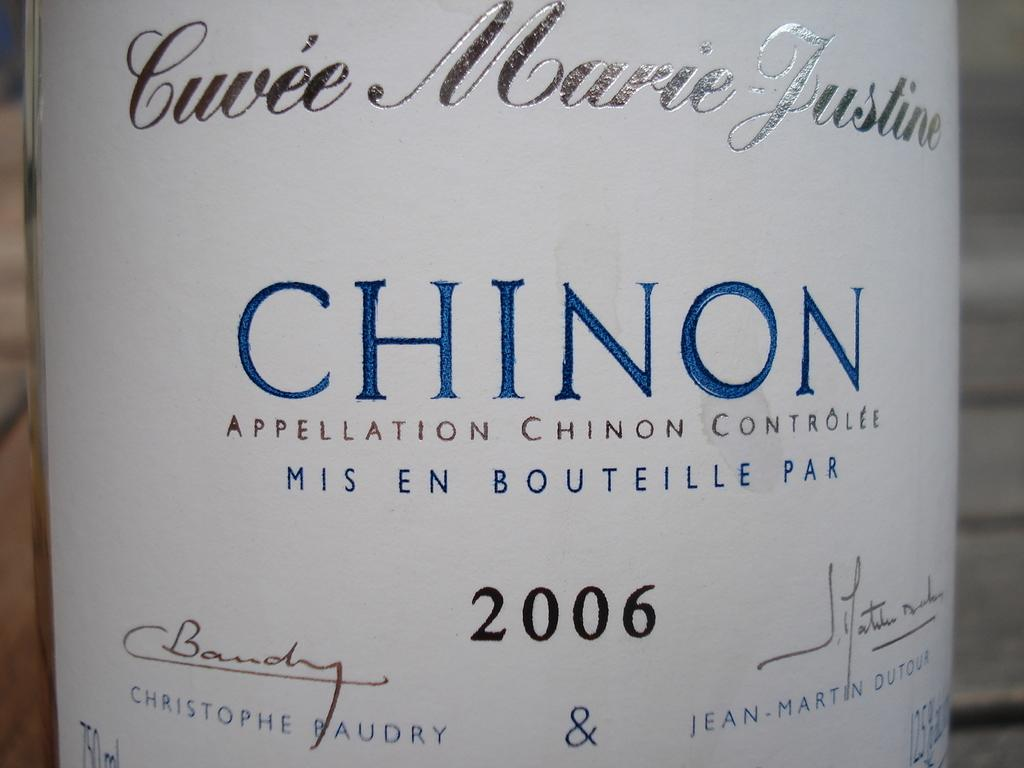<image>
Render a clear and concise summary of the photo. the year 2006 is written on a wine bottle 